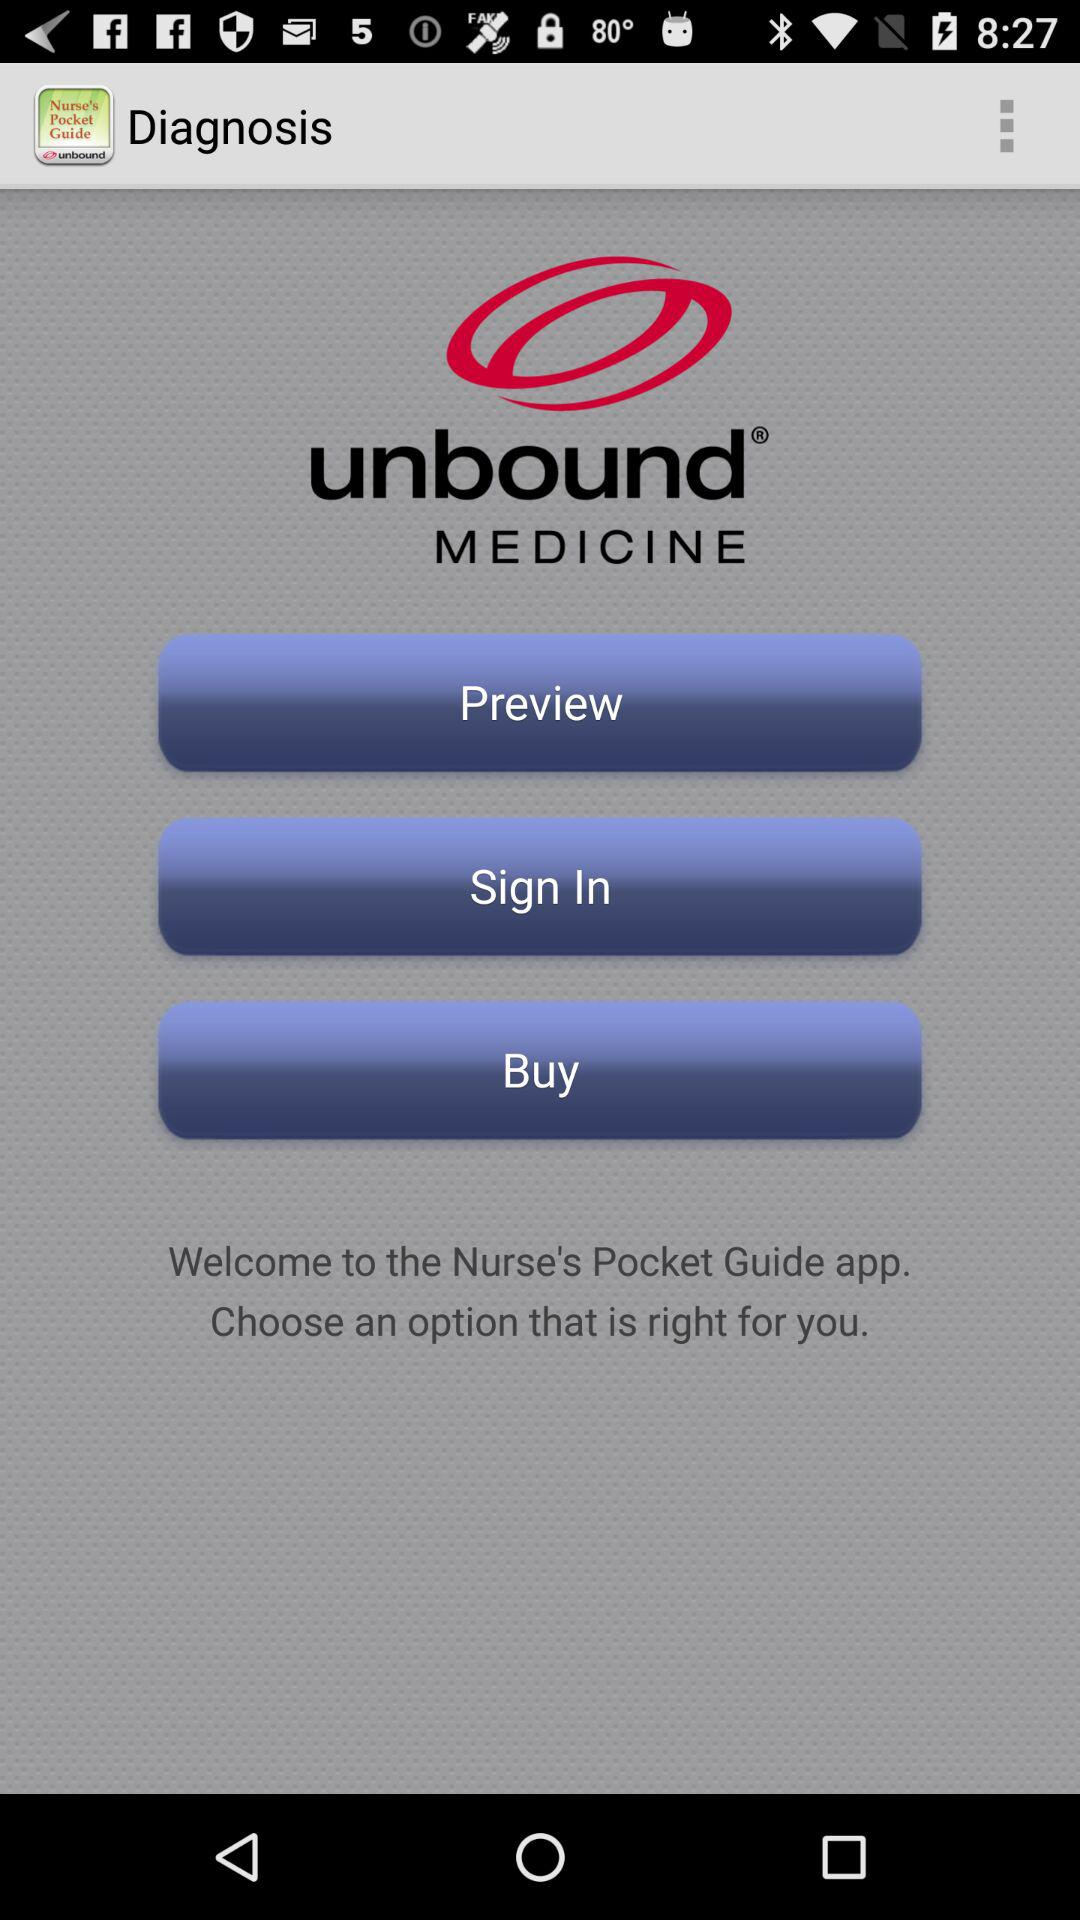What is the application name? The application name is "Nurse's Pocket Guide". 